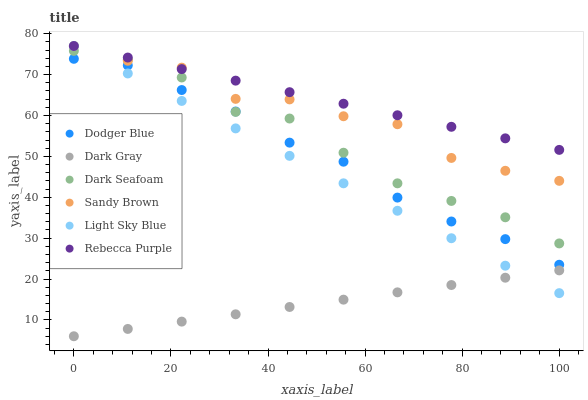Does Dark Gray have the minimum area under the curve?
Answer yes or no. Yes. Does Rebecca Purple have the maximum area under the curve?
Answer yes or no. Yes. Does Dark Seafoam have the minimum area under the curve?
Answer yes or no. No. Does Dark Seafoam have the maximum area under the curve?
Answer yes or no. No. Is Dark Gray the smoothest?
Answer yes or no. Yes. Is Sandy Brown the roughest?
Answer yes or no. Yes. Is Dark Seafoam the smoothest?
Answer yes or no. No. Is Dark Seafoam the roughest?
Answer yes or no. No. Does Dark Gray have the lowest value?
Answer yes or no. Yes. Does Dark Seafoam have the lowest value?
Answer yes or no. No. Does Sandy Brown have the highest value?
Answer yes or no. Yes. Does Dark Seafoam have the highest value?
Answer yes or no. No. Is Dark Gray less than Sandy Brown?
Answer yes or no. Yes. Is Dodger Blue greater than Dark Gray?
Answer yes or no. Yes. Does Sandy Brown intersect Dark Seafoam?
Answer yes or no. Yes. Is Sandy Brown less than Dark Seafoam?
Answer yes or no. No. Is Sandy Brown greater than Dark Seafoam?
Answer yes or no. No. Does Dark Gray intersect Sandy Brown?
Answer yes or no. No. 